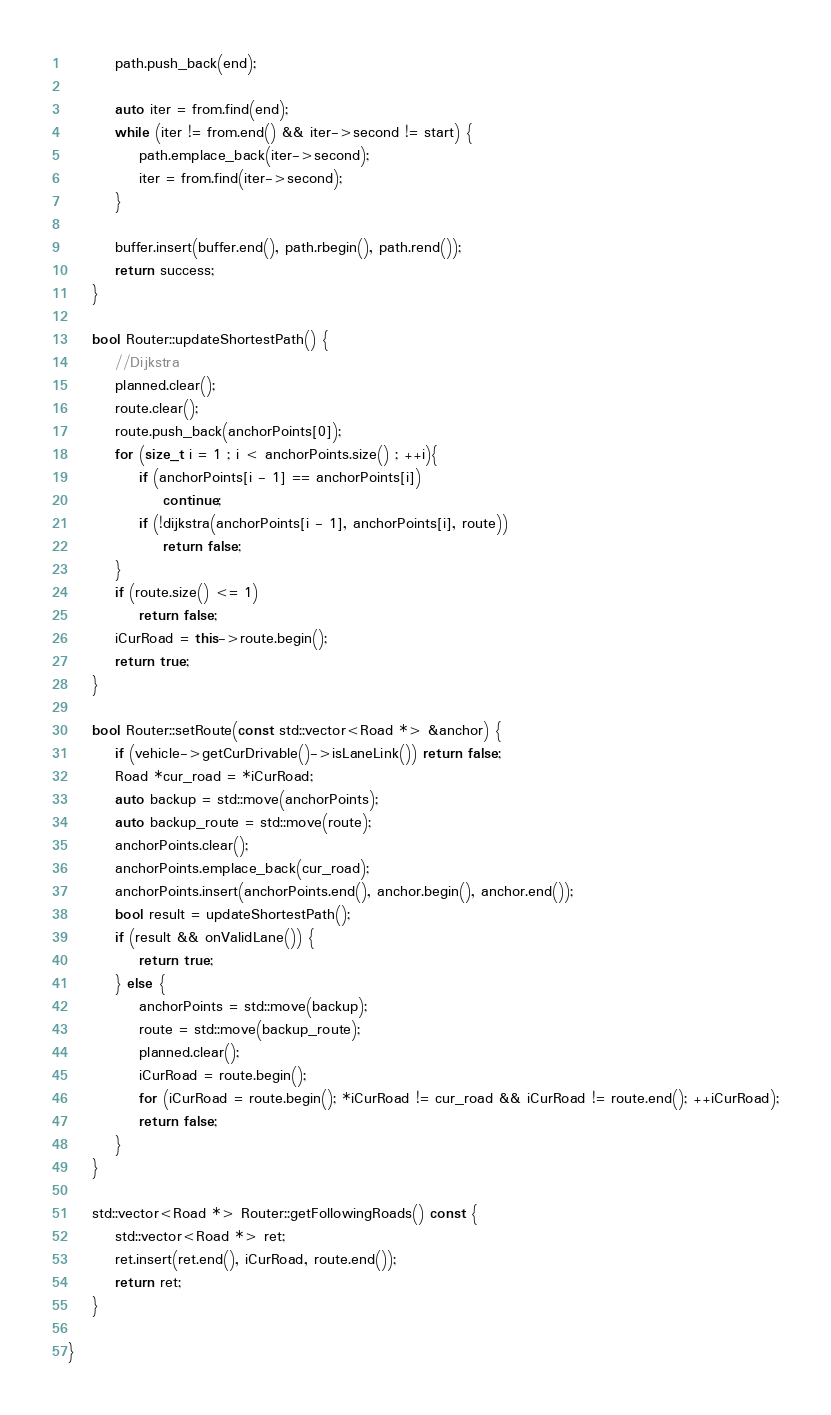Convert code to text. <code><loc_0><loc_0><loc_500><loc_500><_C++_>        path.push_back(end);

        auto iter = from.find(end);
        while (iter != from.end() && iter->second != start) {
            path.emplace_back(iter->second);
            iter = from.find(iter->second);
        }

        buffer.insert(buffer.end(), path.rbegin(), path.rend());
        return success;
    }

    bool Router::updateShortestPath() {
        //Dijkstra
        planned.clear();
        route.clear();
        route.push_back(anchorPoints[0]);
        for (size_t i = 1 ; i < anchorPoints.size() ; ++i){
            if (anchorPoints[i - 1] == anchorPoints[i])
                continue;
            if (!dijkstra(anchorPoints[i - 1], anchorPoints[i], route))
                return false;
        }
        if (route.size() <= 1)
            return false;
        iCurRoad = this->route.begin();
        return true;
    }

    bool Router::setRoute(const std::vector<Road *> &anchor) {
        if (vehicle->getCurDrivable()->isLaneLink()) return false;
        Road *cur_road = *iCurRoad;
        auto backup = std::move(anchorPoints);
        auto backup_route = std::move(route);
        anchorPoints.clear();
        anchorPoints.emplace_back(cur_road);
        anchorPoints.insert(anchorPoints.end(), anchor.begin(), anchor.end());
        bool result = updateShortestPath();
        if (result && onValidLane()) {
            return true;
        } else {
            anchorPoints = std::move(backup);
            route = std::move(backup_route);
            planned.clear();
            iCurRoad = route.begin();
            for (iCurRoad = route.begin(); *iCurRoad != cur_road && iCurRoad != route.end(); ++iCurRoad);
            return false;
        }
    }

    std::vector<Road *> Router::getFollowingRoads() const {
        std::vector<Road *> ret;
        ret.insert(ret.end(), iCurRoad, route.end());
        return ret;
    }

}
</code> 